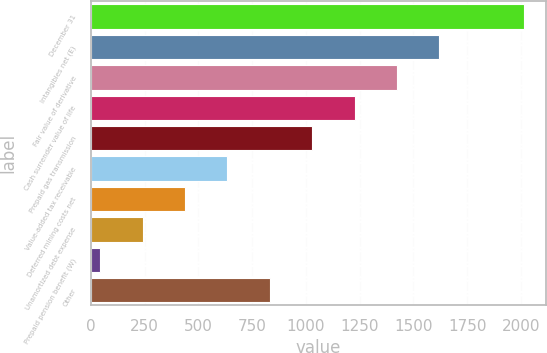Convert chart. <chart><loc_0><loc_0><loc_500><loc_500><bar_chart><fcel>December 31<fcel>Intangibles net (E)<fcel>Fair value of derivative<fcel>Cash surrender value of life<fcel>Prepaid gas transmission<fcel>Value-added tax receivable<fcel>Deferred mining costs net<fcel>Unamortized debt expense<fcel>Prepaid pension benefit (W)<fcel>Other<nl><fcel>2015<fcel>1620.8<fcel>1423.7<fcel>1226.6<fcel>1029.5<fcel>635.3<fcel>438.2<fcel>241.1<fcel>44<fcel>832.4<nl></chart> 